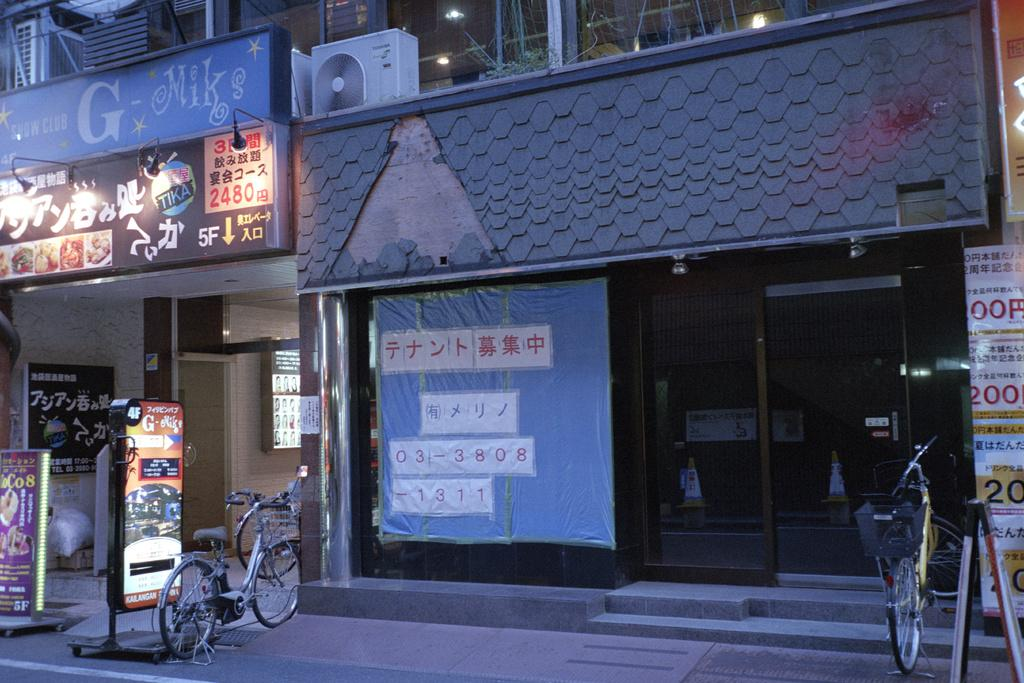What type of establishments can be seen in the image? There are shops in the image. What mode of transportation is visible in the image? There are bicycles in the image. What objects are present in the image that might be used for displaying information or advertisements? There are boards in the image. How many rabbits can be seen hopping around the shops in the image? There are no rabbits present in the image. What type of unit is being measured or displayed on the boards in the image? The provided facts do not mention any specific unit being measured or displayed on the boards. 